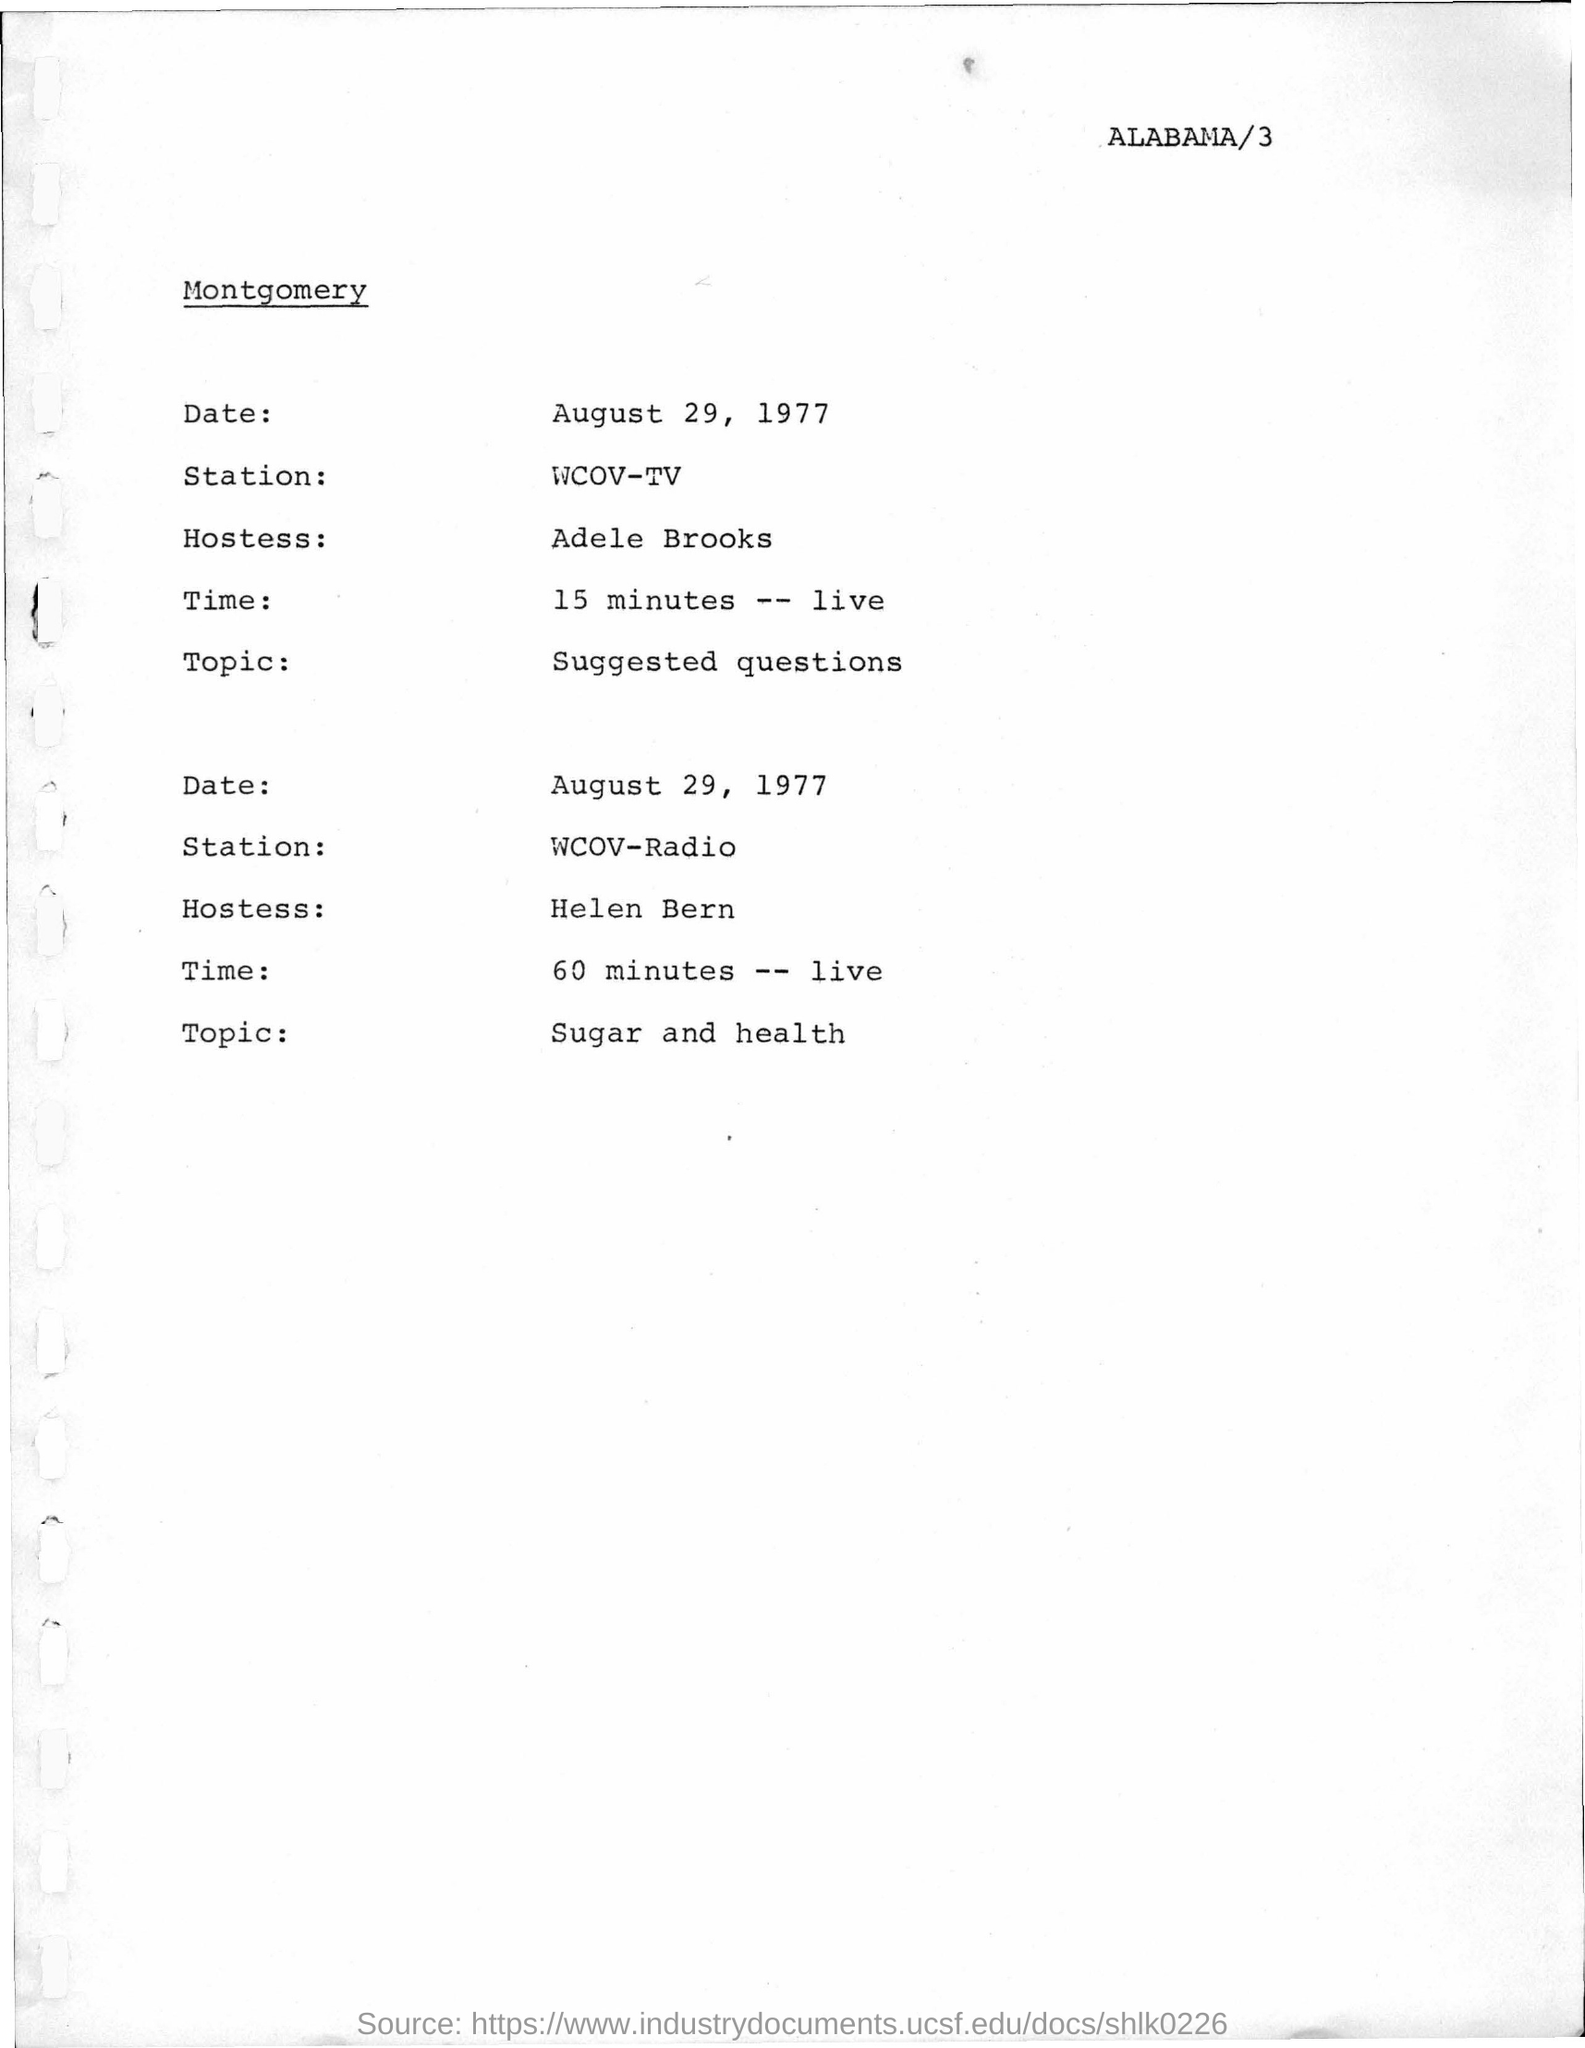What is the date mentioned in the given page ?
Offer a very short reply. August 29, 1977. What is the topic mentioned in the 2nd para ?
Your response must be concise. Sugar and health. 